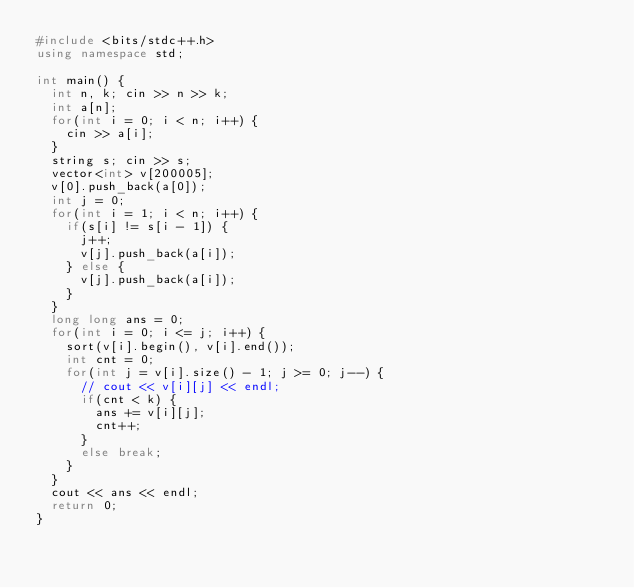<code> <loc_0><loc_0><loc_500><loc_500><_C++_>#include <bits/stdc++.h>
using namespace std;

int main() {
  int n, k; cin >> n >> k;
  int a[n];
  for(int i = 0; i < n; i++) {
    cin >> a[i];
  }
  string s; cin >> s;
  vector<int> v[200005];
  v[0].push_back(a[0]);
  int j = 0;
  for(int i = 1; i < n; i++) {
    if(s[i] != s[i - 1]) {
      j++;
      v[j].push_back(a[i]);
    } else {
      v[j].push_back(a[i]);
    }
  }
  long long ans = 0;
  for(int i = 0; i <= j; i++) {
    sort(v[i].begin(), v[i].end());
    int cnt = 0;
    for(int j = v[i].size() - 1; j >= 0; j--) {
      // cout << v[i][j] << endl;
      if(cnt < k) {
        ans += v[i][j];
        cnt++;
      }
      else break;
    }
  }
  cout << ans << endl;
  return 0;
}
</code> 